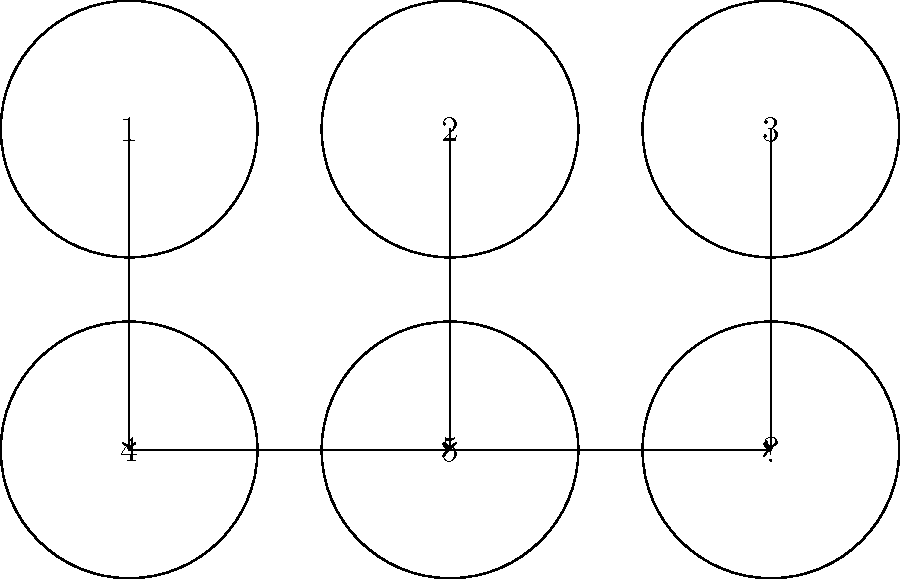In the visual sequence depicting the steps of implementing a mental health awareness program in a religious community, what is the most likely step to replace the question mark? To determine the missing step, let's analyze the sequence:

1. Step 1: This likely represents the initial assessment of the community's mental health needs.
2. Step 2: This could be the planning phase, where strategies are developed based on the assessment.
3. Step 3: This might represent the training of religious leaders and volunteers on mental health topics.
4. Step 4: This step likely involves the actual implementation of awareness programs and initiatives.
5. Step 5: This could represent the ongoing support and resources provided to the community.

Given this sequence, the logical final step would be:

6. Evaluation and feedback: This step would involve assessing the effectiveness of the program, gathering feedback from participants, and making necessary adjustments for future implementations.

This final step is crucial for ensuring the long-term success and improvement of the mental health awareness program within the religious community.
Answer: Evaluation and feedback 